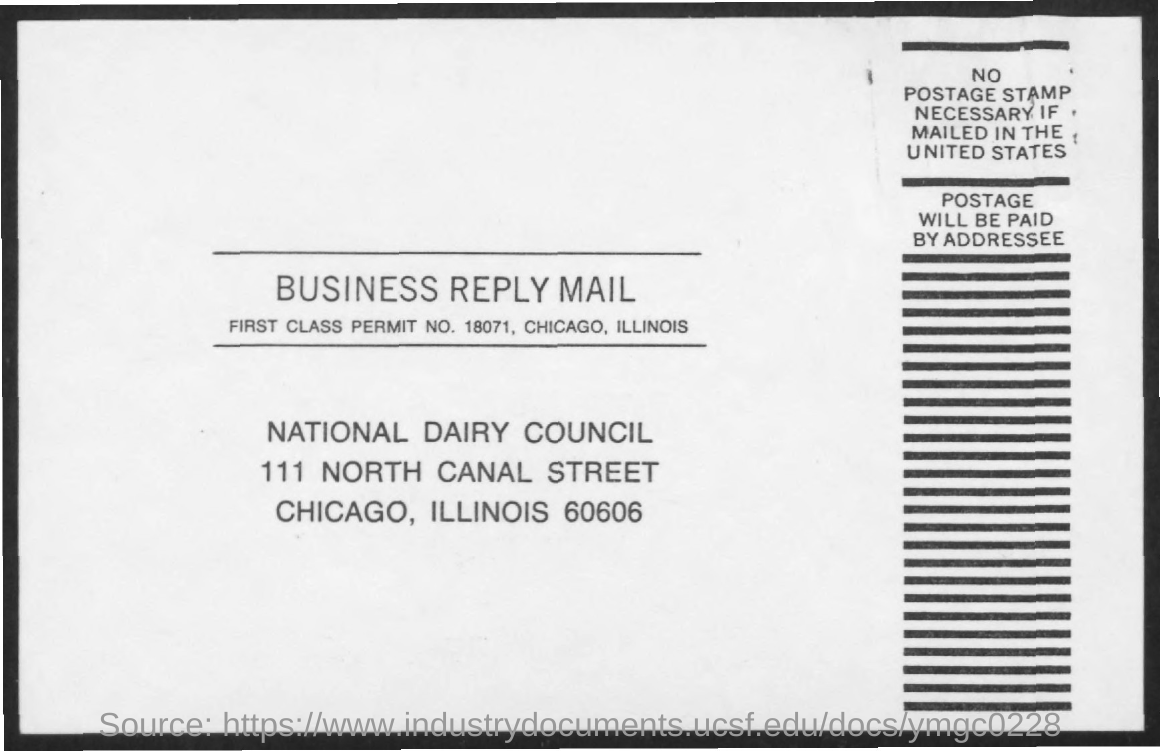What is the first class permit no. mentioned in the business reply mail?
Ensure brevity in your answer.  18071. 